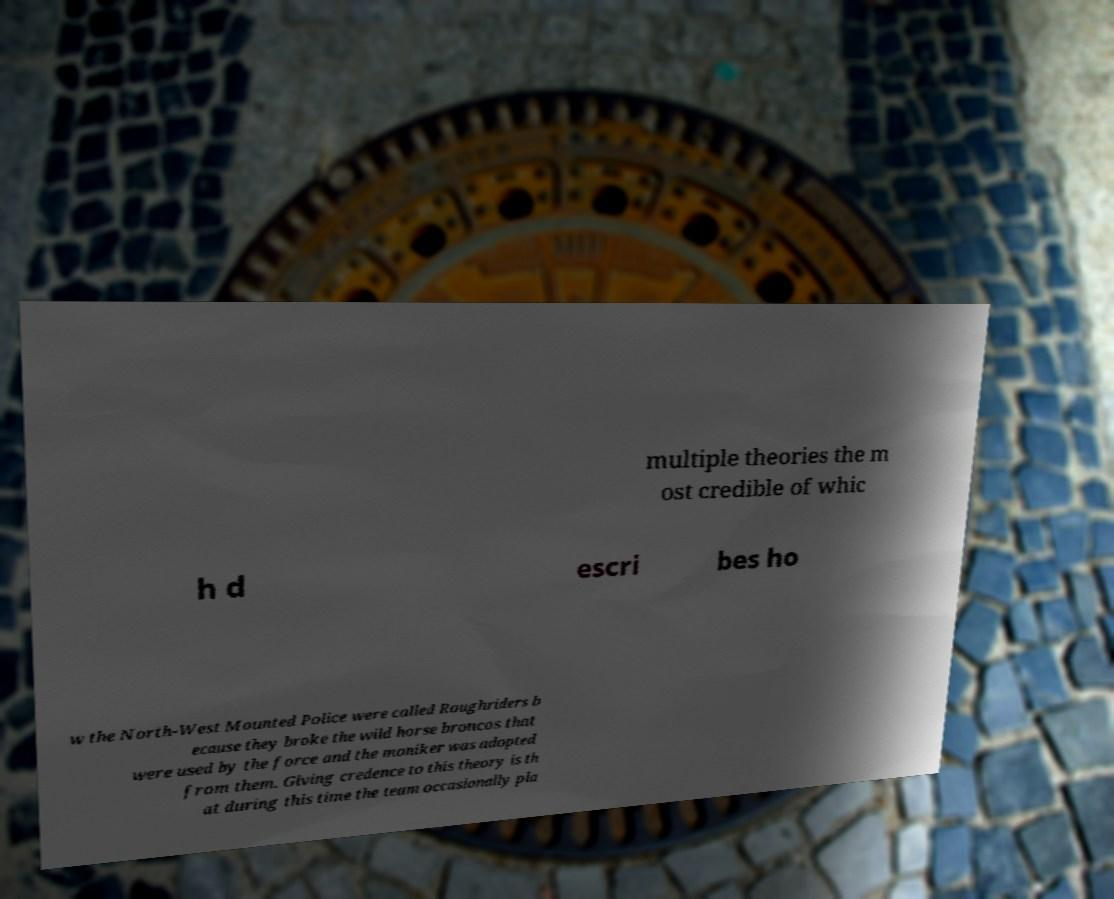Please read and relay the text visible in this image. What does it say? multiple theories the m ost credible of whic h d escri bes ho w the North-West Mounted Police were called Roughriders b ecause they broke the wild horse broncos that were used by the force and the moniker was adopted from them. Giving credence to this theory is th at during this time the team occasionally pla 